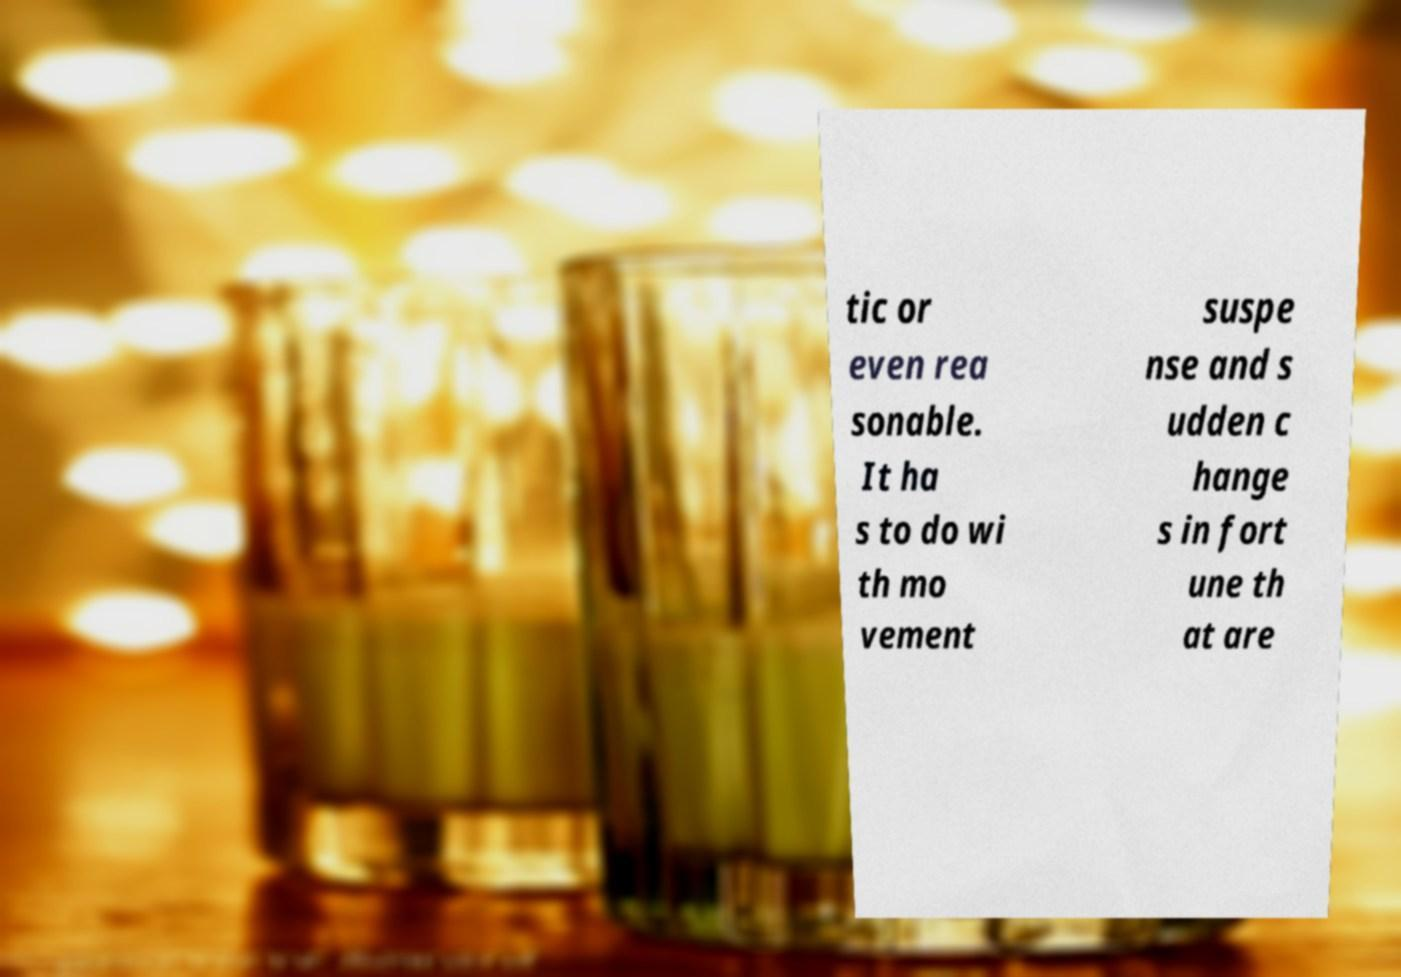I need the written content from this picture converted into text. Can you do that? tic or even rea sonable. It ha s to do wi th mo vement suspe nse and s udden c hange s in fort une th at are 